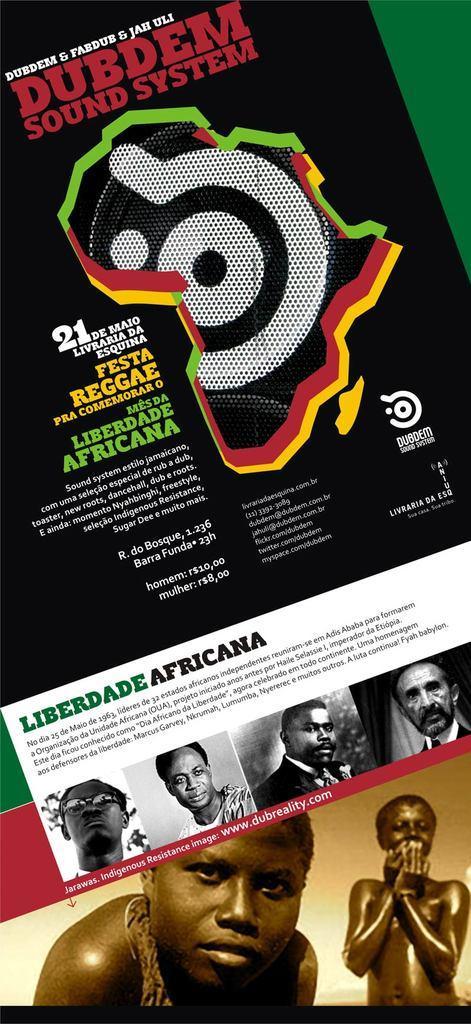Can you describe this image briefly? It is a poster. In this image there are depictions of people and there is some text on the image. 